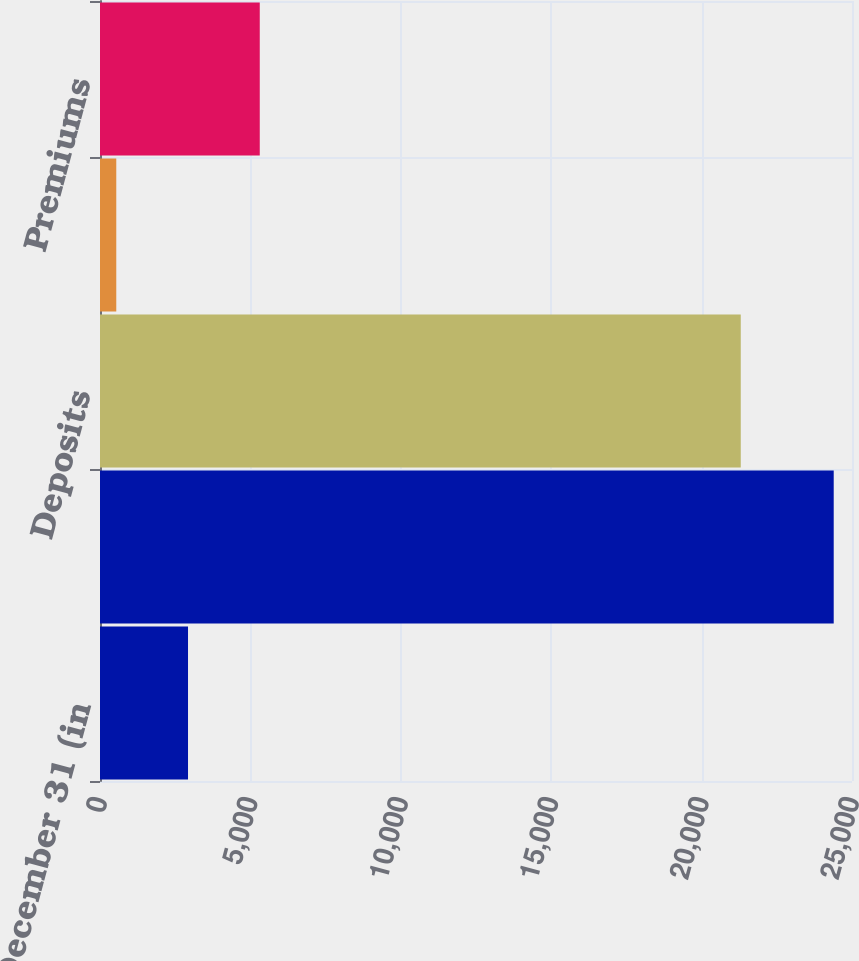Convert chart to OTSL. <chart><loc_0><loc_0><loc_500><loc_500><bar_chart><fcel>Years Ended December 31 (in<fcel>Premiums and deposits<fcel>Deposits<fcel>Other<fcel>Premiums<nl><fcel>2926.1<fcel>24392<fcel>21302<fcel>541<fcel>5311.2<nl></chart> 